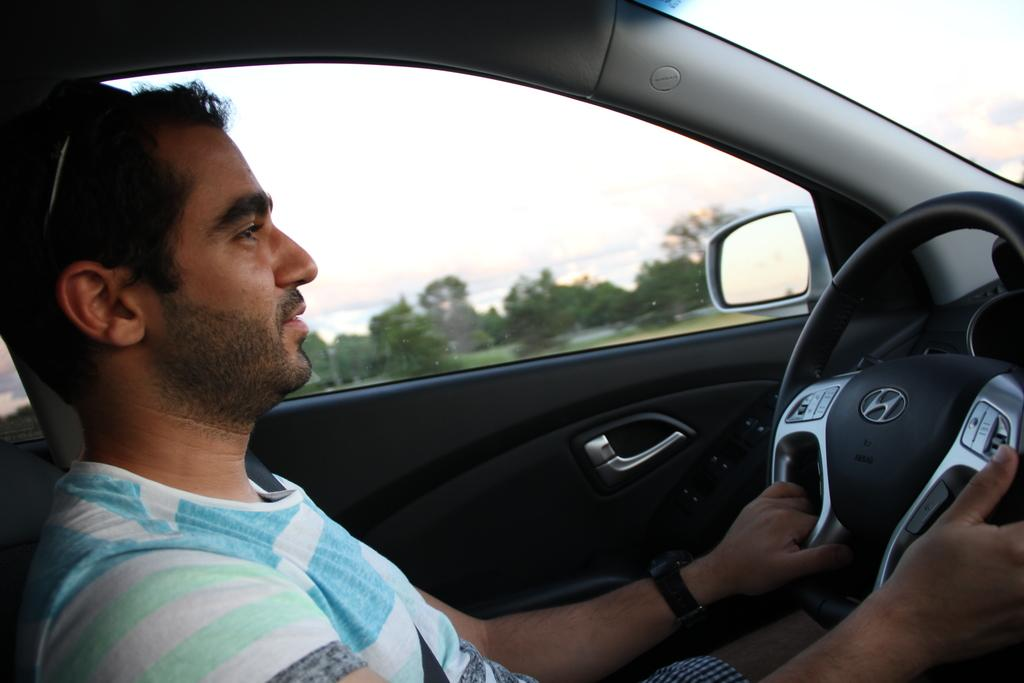What is inside the car in the image? There is a person inside the car. What object is present for the purpose of self-reflection or checking one's appearance? There is a mirror in the car. How can the person inside the car enter or exit the vehicle? There is a door in the car. What is used to control the direction and speed of the car? There is a steering wheel in the car. What can be seen through the car window? The sky and trees are visible through the car window. Where are the mice hiding in the car? There are no mice present in the image. What type of notebook is the person using to write in the car? There is no notebook visible in the image. 